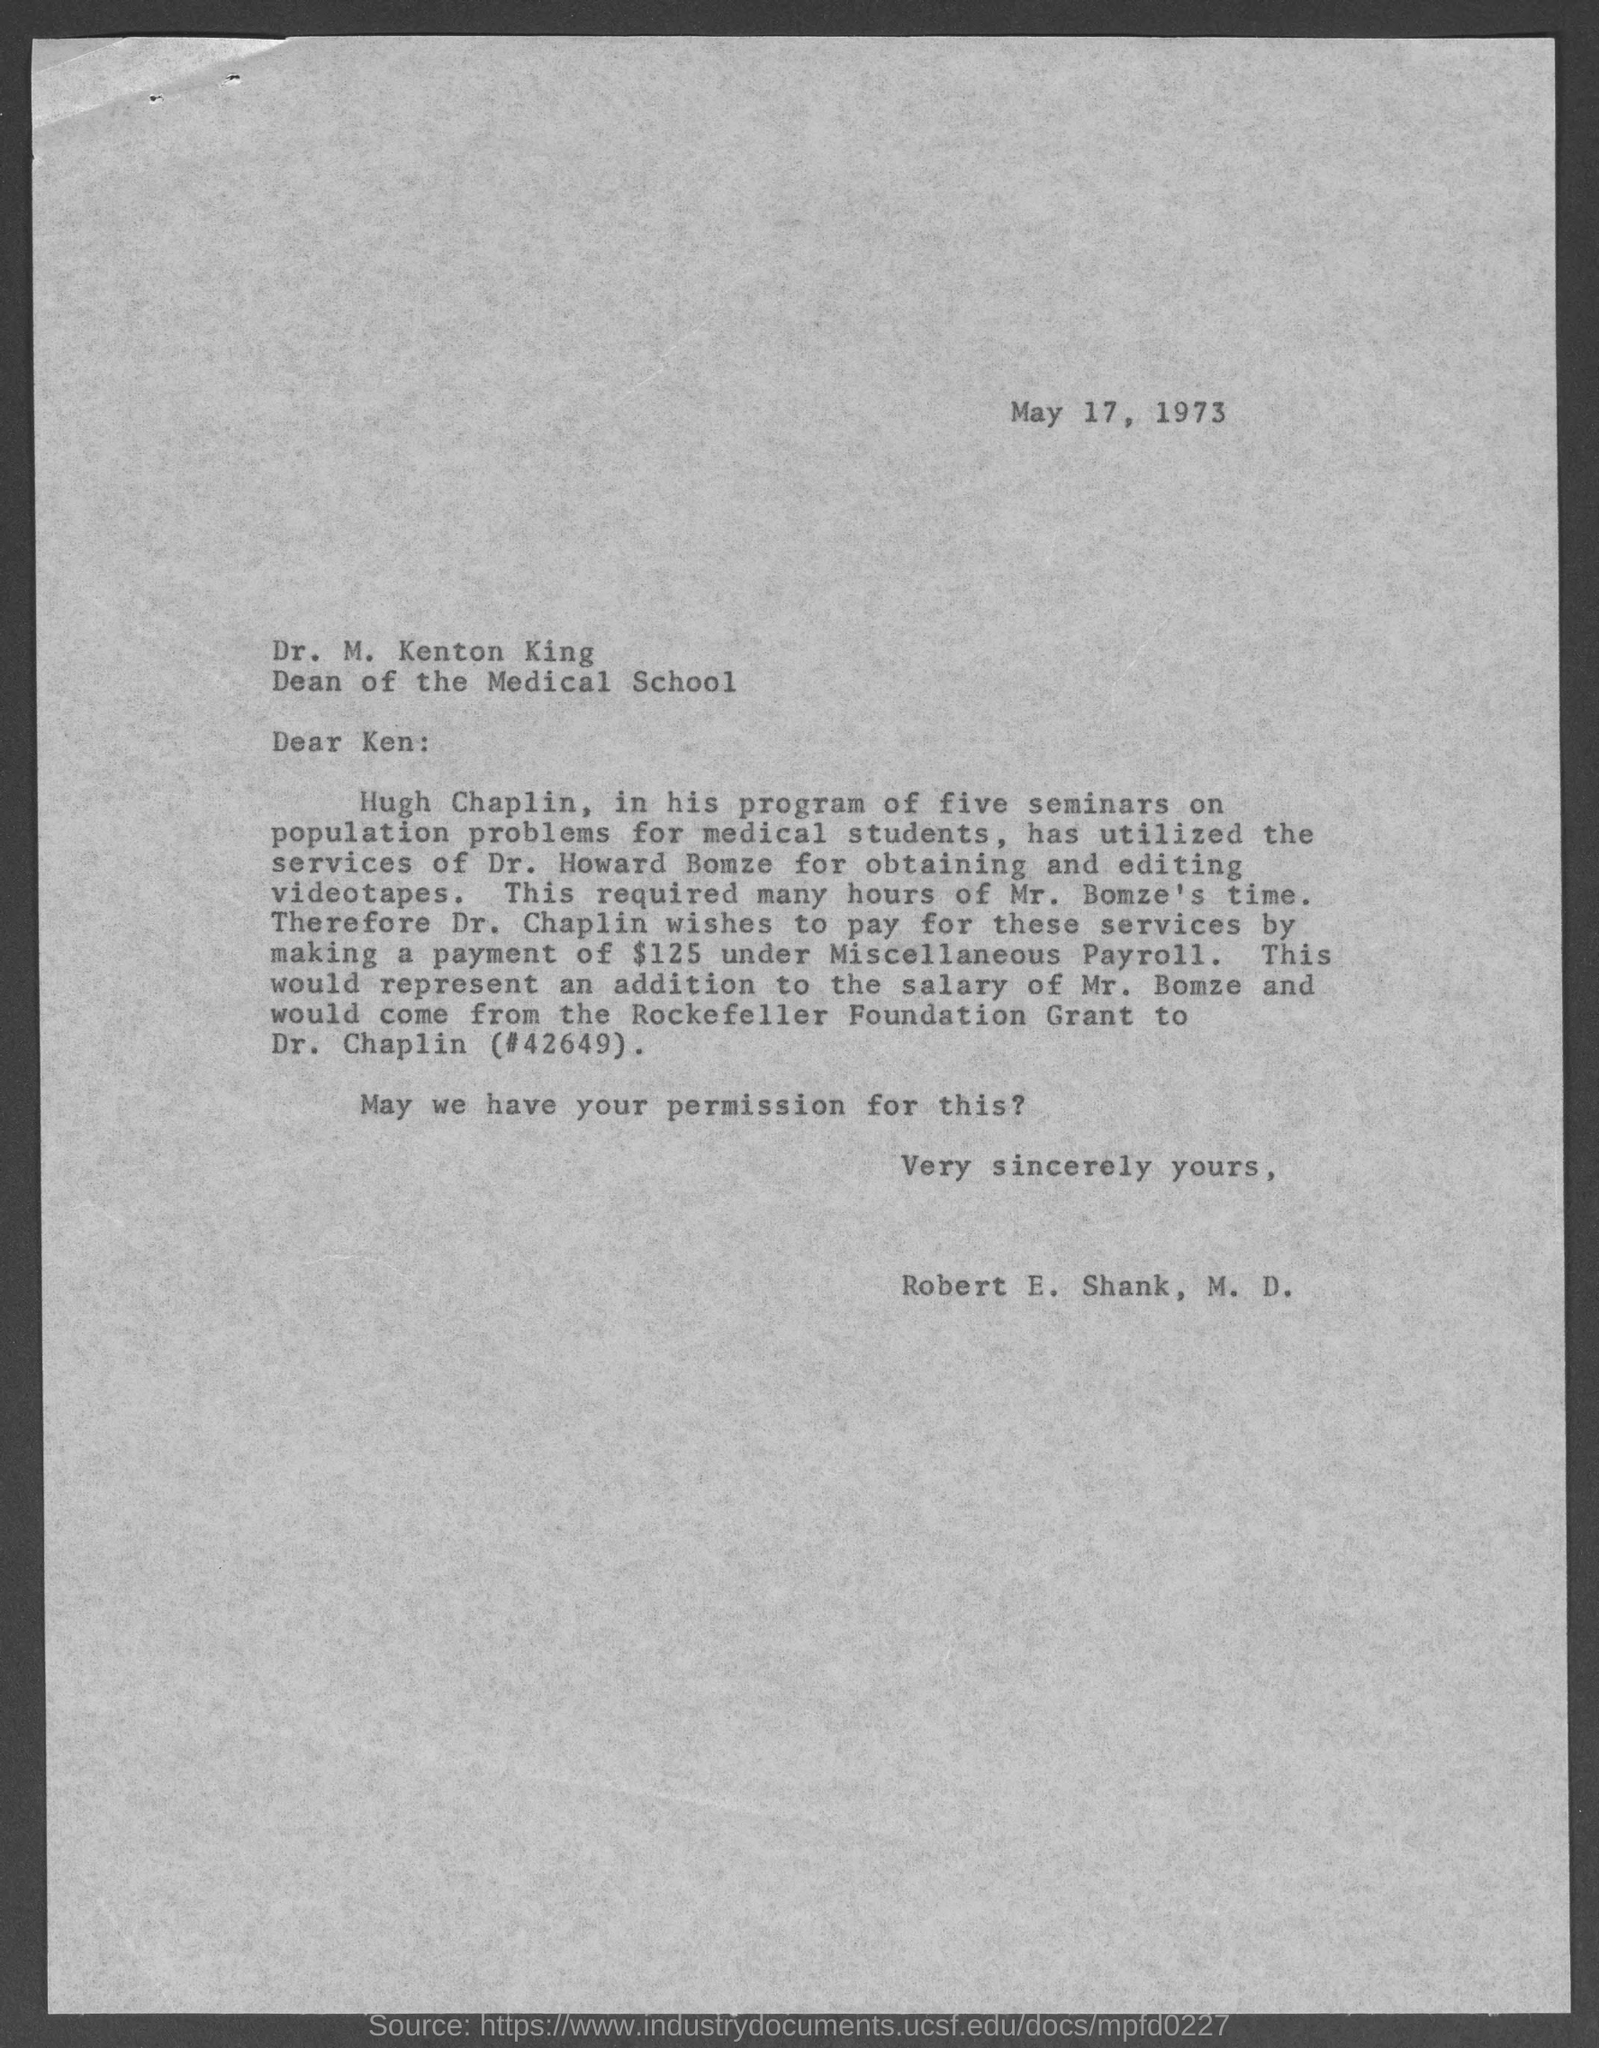Mention a couple of crucial points in this snapshot. The memo was dated May 17, 1973. The memorandum is from Robert E. Shank, M.D. 